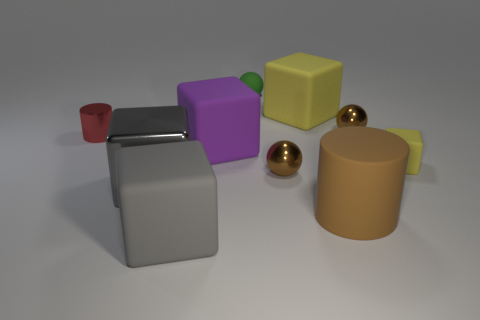How many brown spheres must be subtracted to get 1 brown spheres? 1 Subtract all tiny yellow cubes. How many cubes are left? 4 Subtract all purple cubes. How many cubes are left? 4 Subtract all cyan blocks. Subtract all gray spheres. How many blocks are left? 5 Subtract all cylinders. How many objects are left? 8 Add 3 big blocks. How many big blocks are left? 7 Add 4 big brown cylinders. How many big brown cylinders exist? 5 Subtract 2 brown spheres. How many objects are left? 8 Subtract all big brown matte objects. Subtract all rubber cylinders. How many objects are left? 8 